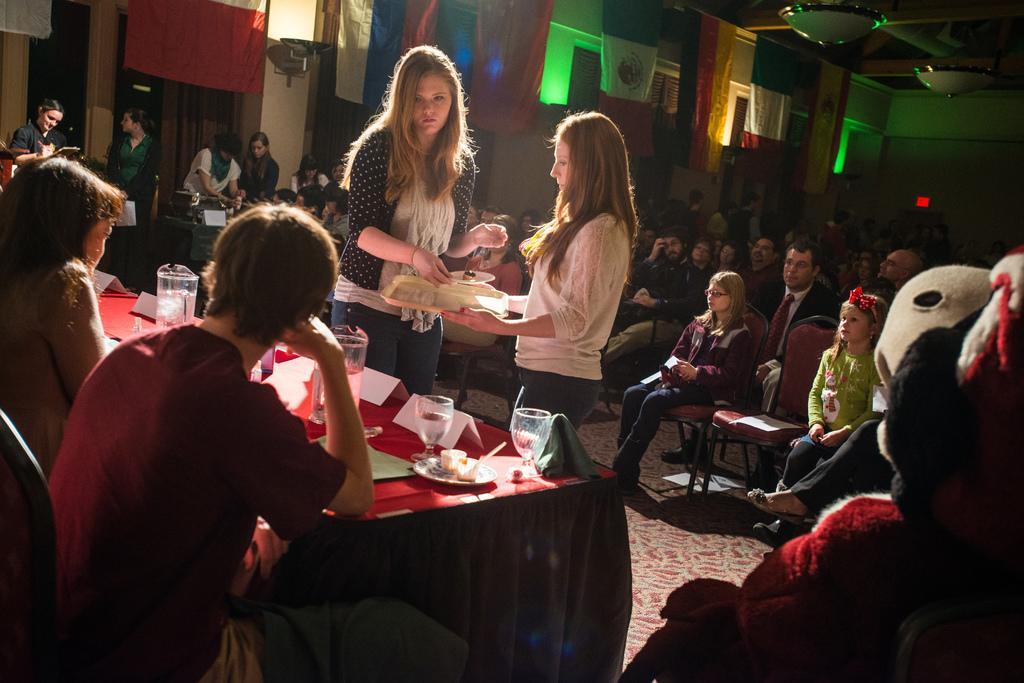Can you describe this image briefly? In this image, at the left side there is a table, on that table there are some glasses and there is a jug, there are some people sitting on the chairs beside the table, there are two girls standing, at the background there are two some people sitting on the cars, there are some curtains. 